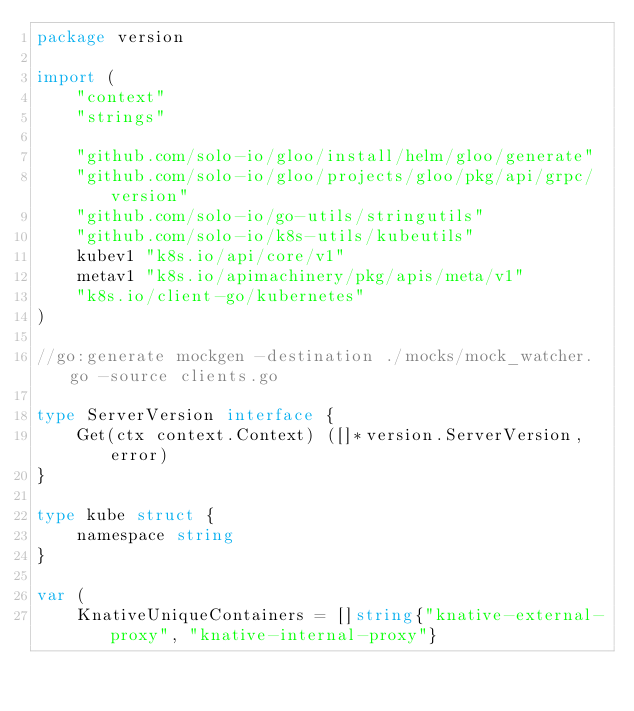Convert code to text. <code><loc_0><loc_0><loc_500><loc_500><_Go_>package version

import (
	"context"
	"strings"

	"github.com/solo-io/gloo/install/helm/gloo/generate"
	"github.com/solo-io/gloo/projects/gloo/pkg/api/grpc/version"
	"github.com/solo-io/go-utils/stringutils"
	"github.com/solo-io/k8s-utils/kubeutils"
	kubev1 "k8s.io/api/core/v1"
	metav1 "k8s.io/apimachinery/pkg/apis/meta/v1"
	"k8s.io/client-go/kubernetes"
)

//go:generate mockgen -destination ./mocks/mock_watcher.go -source clients.go

type ServerVersion interface {
	Get(ctx context.Context) ([]*version.ServerVersion, error)
}

type kube struct {
	namespace string
}

var (
	KnativeUniqueContainers = []string{"knative-external-proxy", "knative-internal-proxy"}</code> 